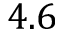Convert formula to latex. <formula><loc_0><loc_0><loc_500><loc_500>4 . 6</formula> 